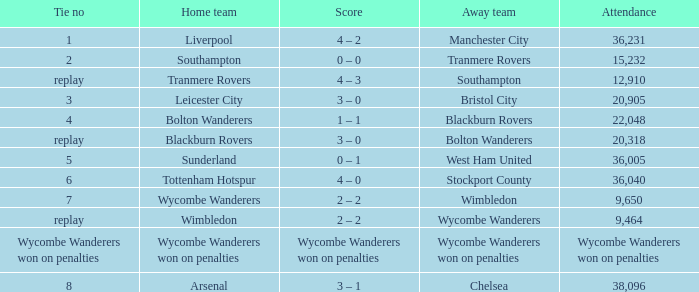What was the outcome for the contest where the home team was leicester city? 3 – 0. 